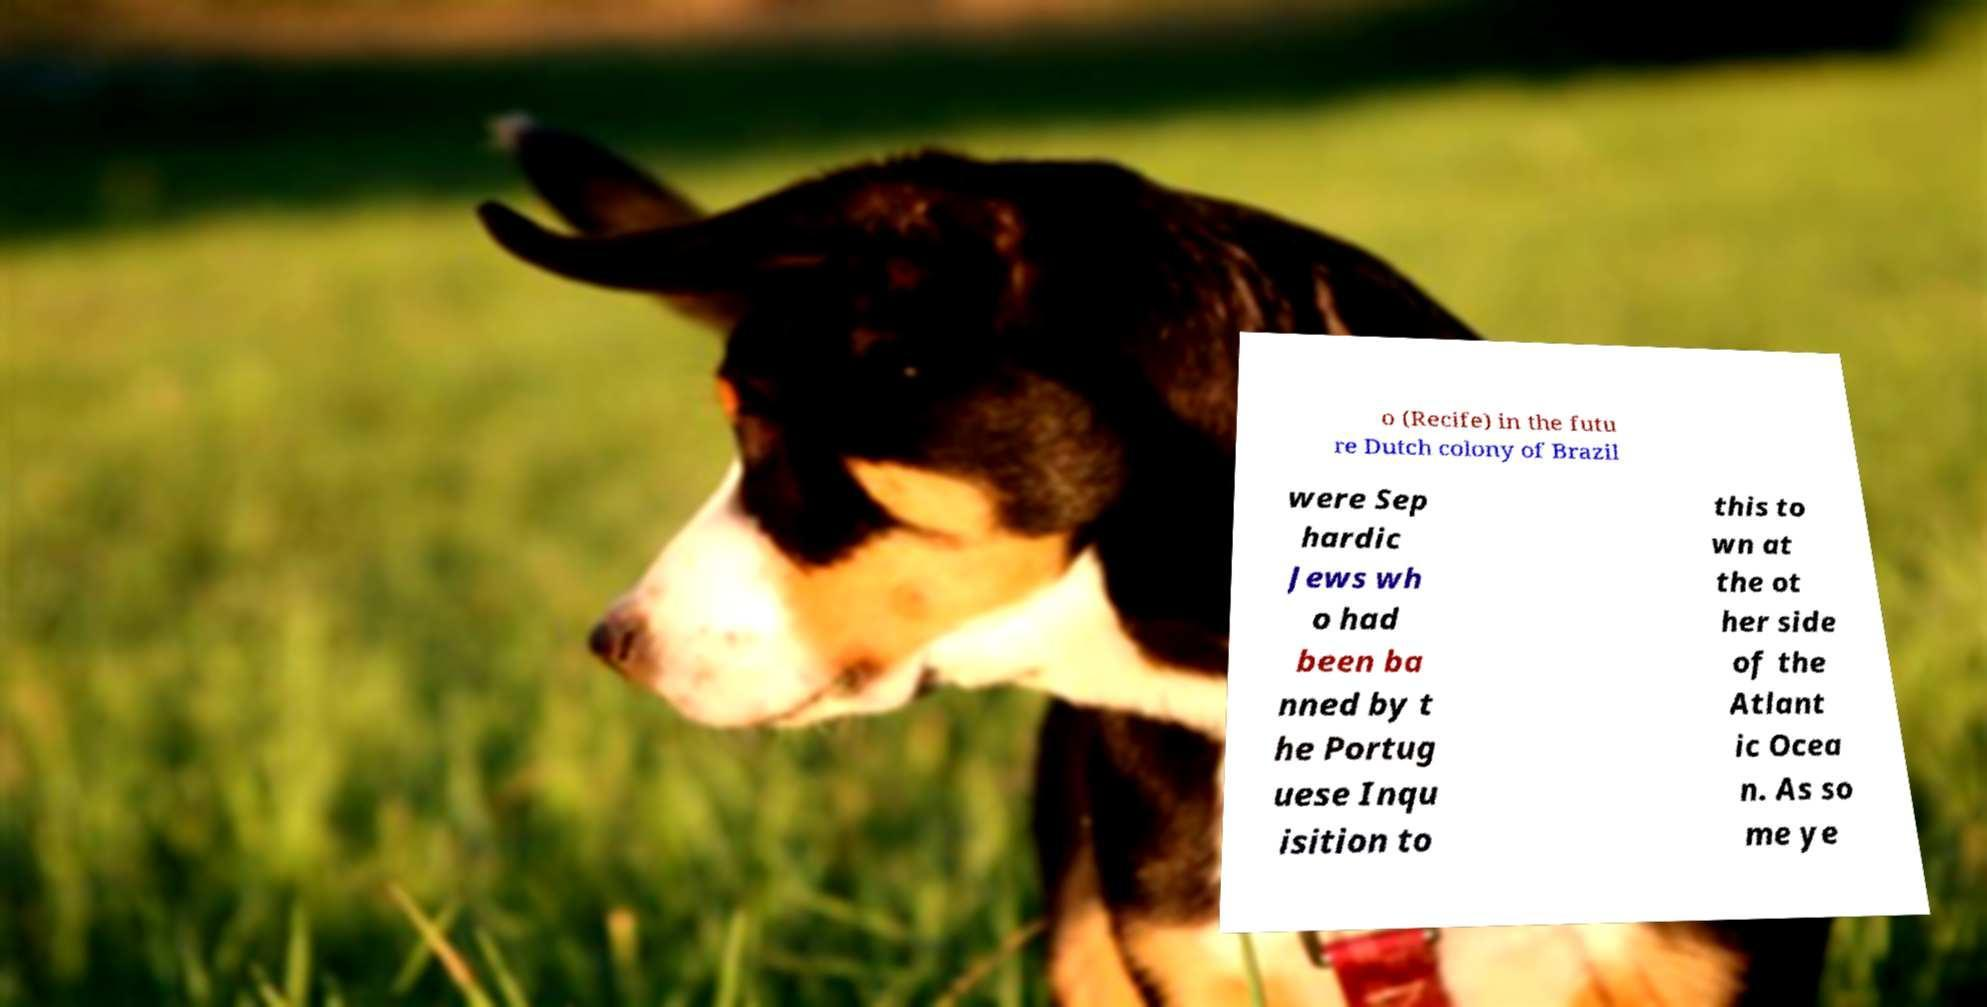There's text embedded in this image that I need extracted. Can you transcribe it verbatim? o (Recife) in the futu re Dutch colony of Brazil were Sep hardic Jews wh o had been ba nned by t he Portug uese Inqu isition to this to wn at the ot her side of the Atlant ic Ocea n. As so me ye 